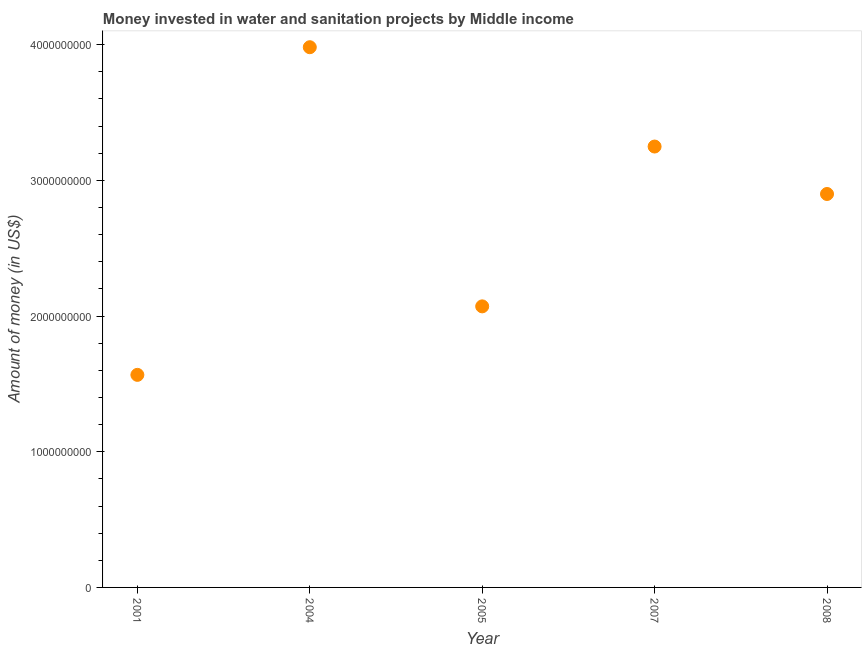What is the investment in 2001?
Provide a succinct answer. 1.57e+09. Across all years, what is the maximum investment?
Offer a terse response. 3.98e+09. Across all years, what is the minimum investment?
Your answer should be compact. 1.57e+09. In which year was the investment maximum?
Make the answer very short. 2004. In which year was the investment minimum?
Give a very brief answer. 2001. What is the sum of the investment?
Keep it short and to the point. 1.38e+1. What is the difference between the investment in 2007 and 2008?
Make the answer very short. 3.50e+08. What is the average investment per year?
Make the answer very short. 2.75e+09. What is the median investment?
Your answer should be very brief. 2.90e+09. In how many years, is the investment greater than 2400000000 US$?
Your response must be concise. 3. Do a majority of the years between 2007 and 2008 (inclusive) have investment greater than 2400000000 US$?
Offer a very short reply. Yes. What is the ratio of the investment in 2005 to that in 2008?
Keep it short and to the point. 0.71. Is the difference between the investment in 2007 and 2008 greater than the difference between any two years?
Your answer should be very brief. No. What is the difference between the highest and the second highest investment?
Your answer should be very brief. 7.32e+08. Is the sum of the investment in 2004 and 2008 greater than the maximum investment across all years?
Provide a short and direct response. Yes. What is the difference between the highest and the lowest investment?
Offer a terse response. 2.41e+09. Does the investment monotonically increase over the years?
Keep it short and to the point. No. How many dotlines are there?
Make the answer very short. 1. How many years are there in the graph?
Provide a short and direct response. 5. Does the graph contain grids?
Make the answer very short. No. What is the title of the graph?
Provide a succinct answer. Money invested in water and sanitation projects by Middle income. What is the label or title of the Y-axis?
Your response must be concise. Amount of money (in US$). What is the Amount of money (in US$) in 2001?
Provide a short and direct response. 1.57e+09. What is the Amount of money (in US$) in 2004?
Provide a succinct answer. 3.98e+09. What is the Amount of money (in US$) in 2005?
Ensure brevity in your answer.  2.07e+09. What is the Amount of money (in US$) in 2007?
Provide a short and direct response. 3.25e+09. What is the Amount of money (in US$) in 2008?
Your response must be concise. 2.90e+09. What is the difference between the Amount of money (in US$) in 2001 and 2004?
Offer a terse response. -2.41e+09. What is the difference between the Amount of money (in US$) in 2001 and 2005?
Your answer should be very brief. -5.05e+08. What is the difference between the Amount of money (in US$) in 2001 and 2007?
Ensure brevity in your answer.  -1.68e+09. What is the difference between the Amount of money (in US$) in 2001 and 2008?
Your answer should be very brief. -1.33e+09. What is the difference between the Amount of money (in US$) in 2004 and 2005?
Keep it short and to the point. 1.91e+09. What is the difference between the Amount of money (in US$) in 2004 and 2007?
Your answer should be very brief. 7.32e+08. What is the difference between the Amount of money (in US$) in 2004 and 2008?
Ensure brevity in your answer.  1.08e+09. What is the difference between the Amount of money (in US$) in 2005 and 2007?
Provide a short and direct response. -1.18e+09. What is the difference between the Amount of money (in US$) in 2005 and 2008?
Provide a short and direct response. -8.28e+08. What is the difference between the Amount of money (in US$) in 2007 and 2008?
Your response must be concise. 3.50e+08. What is the ratio of the Amount of money (in US$) in 2001 to that in 2004?
Make the answer very short. 0.39. What is the ratio of the Amount of money (in US$) in 2001 to that in 2005?
Ensure brevity in your answer.  0.76. What is the ratio of the Amount of money (in US$) in 2001 to that in 2007?
Provide a succinct answer. 0.48. What is the ratio of the Amount of money (in US$) in 2001 to that in 2008?
Your answer should be compact. 0.54. What is the ratio of the Amount of money (in US$) in 2004 to that in 2005?
Give a very brief answer. 1.92. What is the ratio of the Amount of money (in US$) in 2004 to that in 2007?
Keep it short and to the point. 1.23. What is the ratio of the Amount of money (in US$) in 2004 to that in 2008?
Offer a terse response. 1.37. What is the ratio of the Amount of money (in US$) in 2005 to that in 2007?
Your answer should be very brief. 0.64. What is the ratio of the Amount of money (in US$) in 2005 to that in 2008?
Give a very brief answer. 0.71. What is the ratio of the Amount of money (in US$) in 2007 to that in 2008?
Your answer should be very brief. 1.12. 